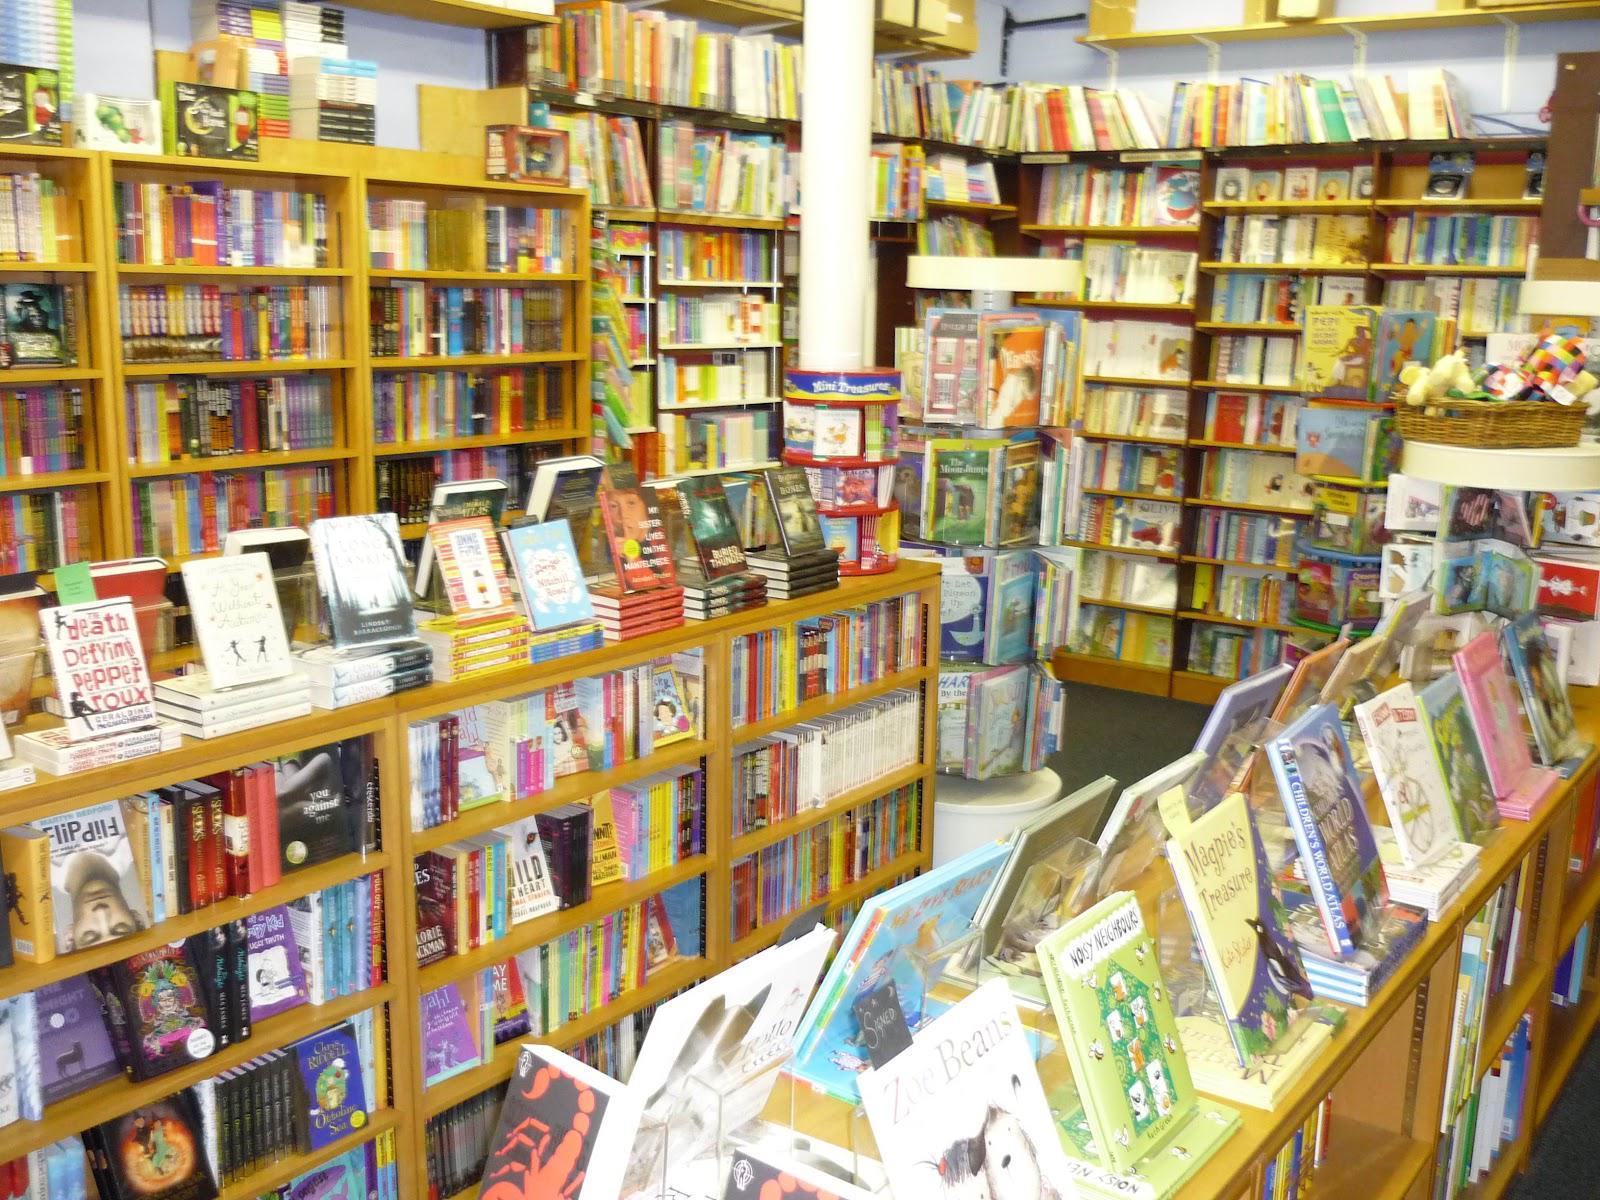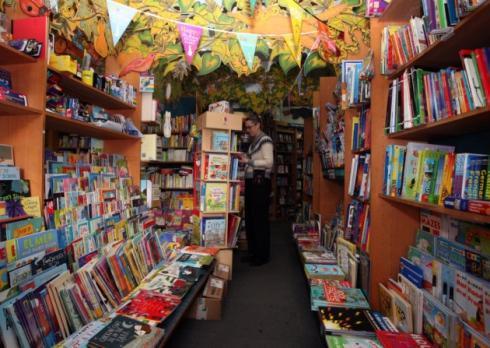The first image is the image on the left, the second image is the image on the right. Analyze the images presented: Is the assertion "In one image, the bookshelves themselves are bright yellow." valid? Answer yes or no. Yes. 